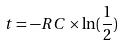<formula> <loc_0><loc_0><loc_500><loc_500>t = - R C \times \ln ( \frac { 1 } { 2 } )</formula> 